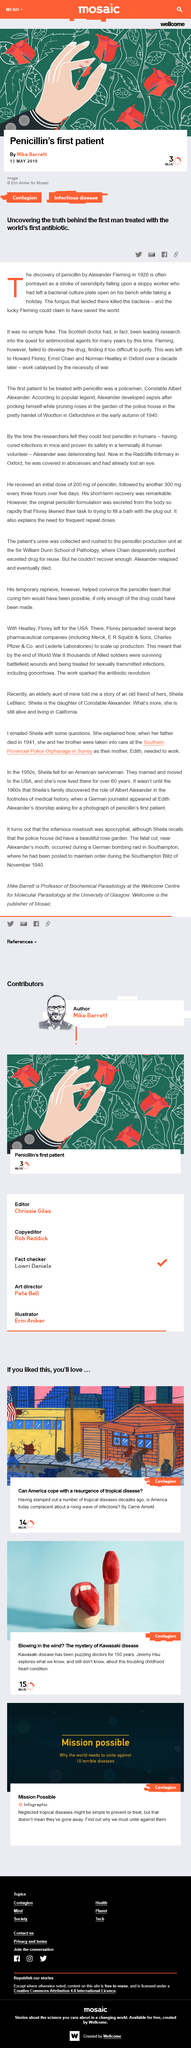Identify some key points in this picture. Alexander Fleming failed to develop the penicillin drug due to his inability to purify the substance, despite finding it to be effective in treating bacterial infections. Howard Florey, Ernst Chain, and Norman Heatley developed penicillin over a decade after the initial discovery of the drug by Alexander Fleming. Alexander Fleming, a Scottish national, was a renowned scientist known for his discovery of penicillin. 